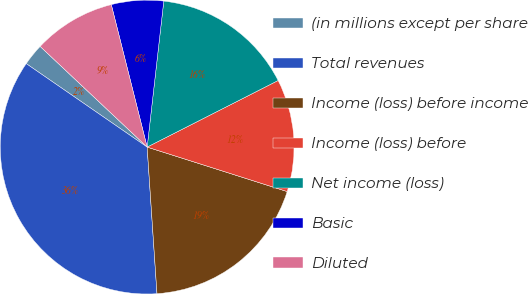Convert chart to OTSL. <chart><loc_0><loc_0><loc_500><loc_500><pie_chart><fcel>(in millions except per share<fcel>Total revenues<fcel>Income (loss) before income<fcel>Income (loss) before<fcel>Net income (loss)<fcel>Basic<fcel>Diluted<nl><fcel>2.4%<fcel>35.68%<fcel>19.04%<fcel>12.38%<fcel>15.71%<fcel>5.73%<fcel>9.06%<nl></chart> 